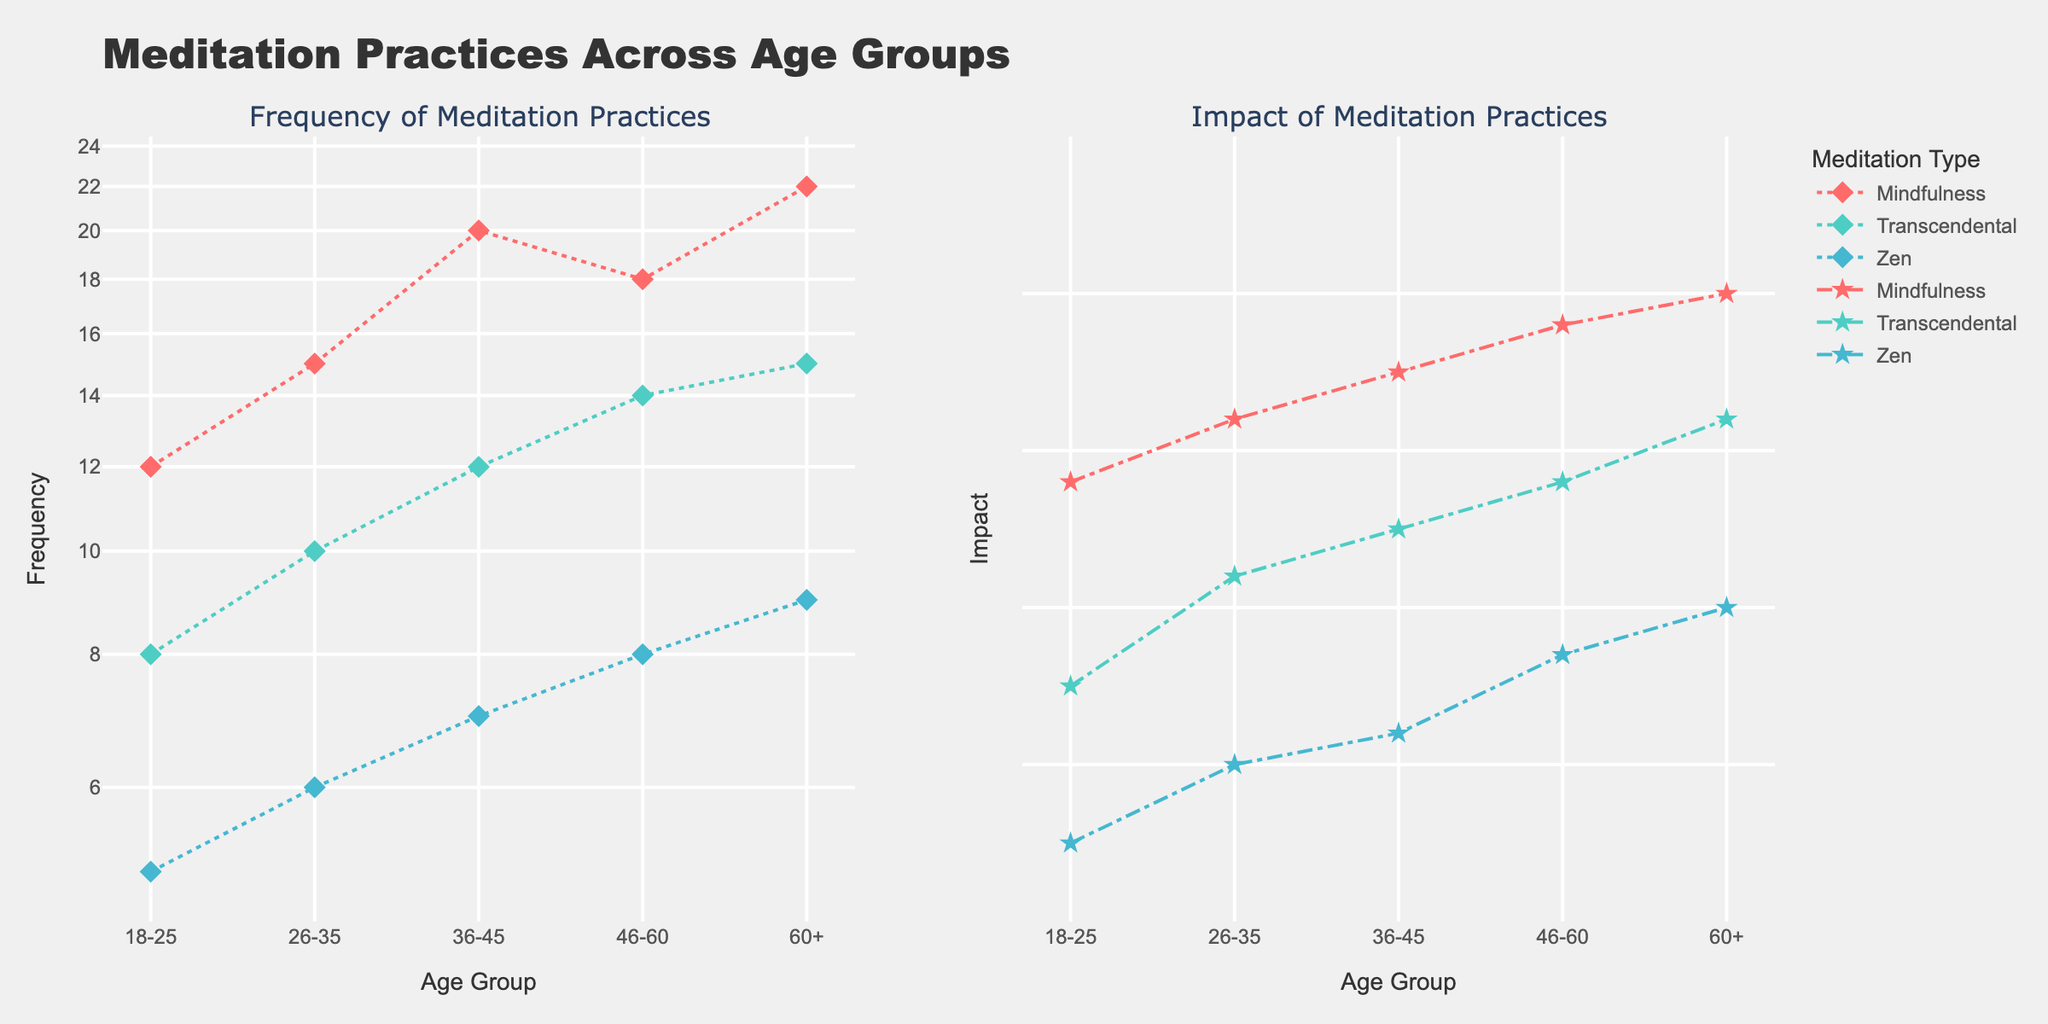What's the title of the figure? The title of a figure is generally placed at the top. By locating and reading the title, we immediately understand the main topic of the figure.
Answer: "Meditation Practices Across Age Groups" What does the y-axis represent in the left subplot? The y-axis of a subplot typically represents the dependent variable. In this case, the left subplot has the y-axis labeled as "Frequency", indicating it shows the frequency of meditation practices.
Answer: Frequency How many age groups are plotted in the figure? By counting the unique labels on the x-axis of any subplot, we can determine the total number of age groups represented.
Answer: 5 Which meditation type has the highest impact for the 60+ age group? By locating the 60+ age group on the x-axis of the right subplot and identifying which meditation type has the highest y-value, we can find the answer.
Answer: Mindfulness Compare the frequency of Mindfulness and Zen meditation for the 26-35 age group. Which has a higher frequency? To compare the frequencies, we look at the left subplot for the 26-35 age group. We find the y-values for both Mindfulness and Zen and compare them.
Answer: Mindfulness What is the trend in the impact of Transcendental meditation across age groups? By observing the right subplot, we trace the line representing Transcendental meditation across all age groups to understand its trend. The trend here is mostly stable or slightly increasing.
Answer: Increasing Calculate the sum of the frequencies of Zen meditation for all age groups. By summing the y-values representing the frequency of Zen meditation across all age groups in the left subplot, we find the total frequency. (5 + 6 + 7 + 8 + 9) = 35
Answer: 35 Which age group sees the highest frequency of meditation practices in general (not specific to type)? We need to find the highest y-value on the left subplot and identify the corresponding age group. The age group 60+ for Mindfulness meditation has the highest frequency (22).
Answer: 60+ Compare the impact of Mindfulness meditation between the 18-25 and 46-60 age groups. How does it change? By looking at the right subplot and comparing the y-values for Mindfulness meditation between the 18-25 and 46-60 age groups, we can see how the impact changes. The impact increases from 0.78 to 0.88.
Answer: Increases Between the 26-35 and 36-45 age groups, which has a greater difference in frequency between Mindfulness and Zen meditation? We need to calculate the frequency difference for both age groups and compare them. For 26-35, the difference is (15 - 6) = 9. For 36-45, the difference is (20 - 7) = 13.
Answer: 36-45 